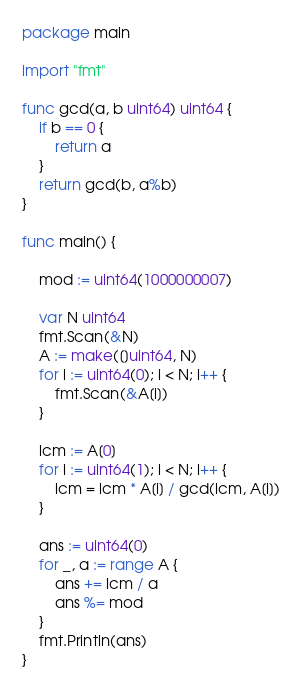Convert code to text. <code><loc_0><loc_0><loc_500><loc_500><_Go_>package main

import "fmt"

func gcd(a, b uint64) uint64 {
	if b == 0 {
		return a
	}
	return gcd(b, a%b)
}

func main() {

	mod := uint64(1000000007)

	var N uint64
	fmt.Scan(&N)
	A := make([]uint64, N)
	for i := uint64(0); i < N; i++ {
		fmt.Scan(&A[i])
	}

	lcm := A[0]
	for i := uint64(1); i < N; i++ {
		lcm = lcm * A[i] / gcd(lcm, A[i])
	}

	ans := uint64(0)
	for _, a := range A {
		ans += lcm / a
		ans %= mod
	}
	fmt.Println(ans)
}
</code> 